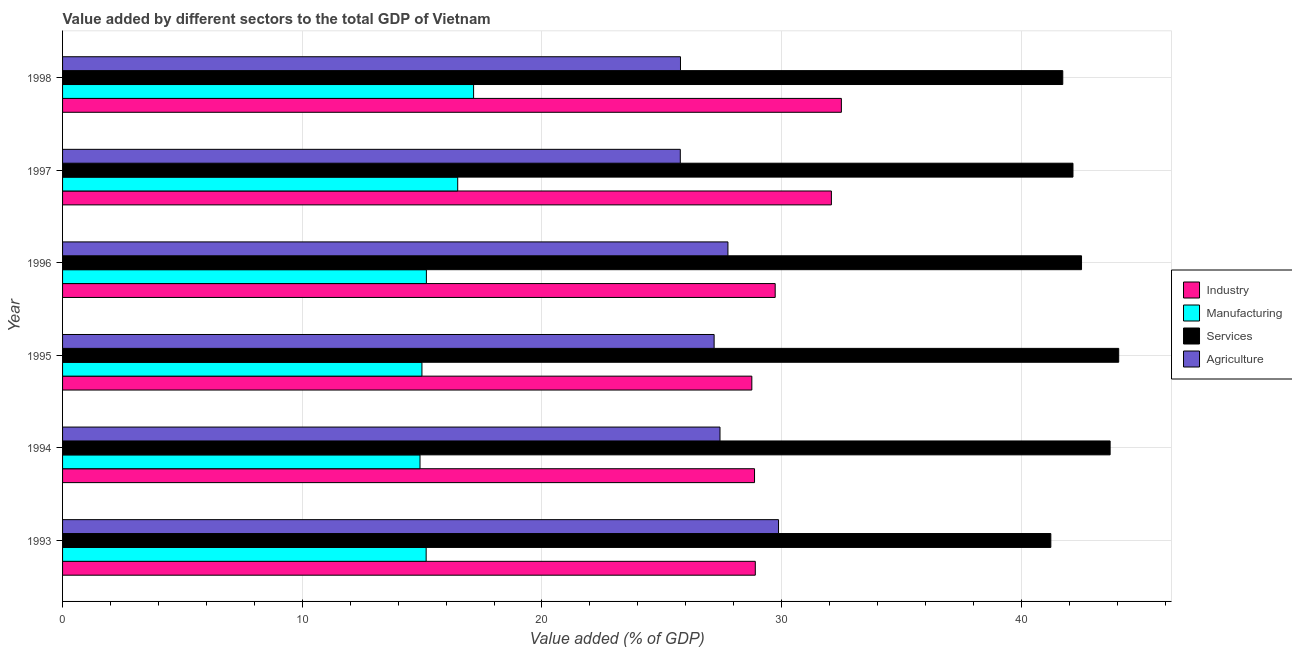How many groups of bars are there?
Ensure brevity in your answer.  6. Are the number of bars per tick equal to the number of legend labels?
Your answer should be compact. Yes. Are the number of bars on each tick of the Y-axis equal?
Provide a short and direct response. Yes. What is the value added by services sector in 1996?
Ensure brevity in your answer.  42.51. Across all years, what is the maximum value added by industrial sector?
Your answer should be very brief. 32.49. Across all years, what is the minimum value added by manufacturing sector?
Your answer should be very brief. 14.91. In which year was the value added by manufacturing sector maximum?
Make the answer very short. 1998. What is the total value added by industrial sector in the graph?
Make the answer very short. 180.82. What is the difference between the value added by agricultural sector in 1996 and that in 1997?
Offer a very short reply. 1.99. What is the difference between the value added by services sector in 1997 and the value added by industrial sector in 1993?
Provide a short and direct response. 13.25. What is the average value added by manufacturing sector per year?
Your answer should be very brief. 15.65. In the year 1998, what is the difference between the value added by manufacturing sector and value added by industrial sector?
Your answer should be compact. -15.34. What is the ratio of the value added by agricultural sector in 1994 to that in 1998?
Keep it short and to the point. 1.06. Is the difference between the value added by manufacturing sector in 1995 and 1998 greater than the difference between the value added by agricultural sector in 1995 and 1998?
Your answer should be very brief. No. What is the difference between the highest and the second highest value added by agricultural sector?
Provide a short and direct response. 2.11. Is the sum of the value added by services sector in 1993 and 1995 greater than the maximum value added by agricultural sector across all years?
Ensure brevity in your answer.  Yes. What does the 2nd bar from the top in 1997 represents?
Your response must be concise. Services. What does the 4th bar from the bottom in 1993 represents?
Give a very brief answer. Agriculture. How many bars are there?
Offer a very short reply. 24. Are the values on the major ticks of X-axis written in scientific E-notation?
Provide a succinct answer. No. How many legend labels are there?
Offer a very short reply. 4. What is the title of the graph?
Keep it short and to the point. Value added by different sectors to the total GDP of Vietnam. Does "Social Assistance" appear as one of the legend labels in the graph?
Make the answer very short. No. What is the label or title of the X-axis?
Ensure brevity in your answer.  Value added (% of GDP). What is the label or title of the Y-axis?
Ensure brevity in your answer.  Year. What is the Value added (% of GDP) in Industry in 1993?
Offer a very short reply. 28.9. What is the Value added (% of GDP) of Manufacturing in 1993?
Your answer should be compact. 15.17. What is the Value added (% of GDP) of Services in 1993?
Provide a succinct answer. 41.23. What is the Value added (% of GDP) in Agriculture in 1993?
Give a very brief answer. 29.87. What is the Value added (% of GDP) in Industry in 1994?
Provide a short and direct response. 28.87. What is the Value added (% of GDP) in Manufacturing in 1994?
Your response must be concise. 14.91. What is the Value added (% of GDP) in Services in 1994?
Give a very brief answer. 43.7. What is the Value added (% of GDP) in Agriculture in 1994?
Offer a very short reply. 27.43. What is the Value added (% of GDP) of Industry in 1995?
Your response must be concise. 28.76. What is the Value added (% of GDP) of Manufacturing in 1995?
Your answer should be compact. 14.99. What is the Value added (% of GDP) in Services in 1995?
Offer a terse response. 44.06. What is the Value added (% of GDP) of Agriculture in 1995?
Make the answer very short. 27.18. What is the Value added (% of GDP) of Industry in 1996?
Offer a very short reply. 29.73. What is the Value added (% of GDP) of Manufacturing in 1996?
Offer a very short reply. 15.18. What is the Value added (% of GDP) of Services in 1996?
Your response must be concise. 42.51. What is the Value added (% of GDP) of Agriculture in 1996?
Keep it short and to the point. 27.76. What is the Value added (% of GDP) of Industry in 1997?
Your answer should be compact. 32.07. What is the Value added (% of GDP) of Manufacturing in 1997?
Your response must be concise. 16.48. What is the Value added (% of GDP) of Services in 1997?
Give a very brief answer. 42.15. What is the Value added (% of GDP) of Agriculture in 1997?
Your answer should be compact. 25.77. What is the Value added (% of GDP) of Industry in 1998?
Provide a succinct answer. 32.49. What is the Value added (% of GDP) of Manufacturing in 1998?
Give a very brief answer. 17.15. What is the Value added (% of GDP) in Services in 1998?
Your answer should be compact. 41.73. What is the Value added (% of GDP) of Agriculture in 1998?
Your answer should be compact. 25.78. Across all years, what is the maximum Value added (% of GDP) in Industry?
Offer a terse response. 32.49. Across all years, what is the maximum Value added (% of GDP) in Manufacturing?
Your answer should be compact. 17.15. Across all years, what is the maximum Value added (% of GDP) of Services?
Provide a short and direct response. 44.06. Across all years, what is the maximum Value added (% of GDP) of Agriculture?
Offer a very short reply. 29.87. Across all years, what is the minimum Value added (% of GDP) in Industry?
Provide a short and direct response. 28.76. Across all years, what is the minimum Value added (% of GDP) of Manufacturing?
Offer a very short reply. 14.91. Across all years, what is the minimum Value added (% of GDP) of Services?
Keep it short and to the point. 41.23. Across all years, what is the minimum Value added (% of GDP) of Agriculture?
Provide a succinct answer. 25.77. What is the total Value added (% of GDP) of Industry in the graph?
Provide a short and direct response. 180.82. What is the total Value added (% of GDP) of Manufacturing in the graph?
Keep it short and to the point. 93.89. What is the total Value added (% of GDP) in Services in the graph?
Offer a very short reply. 255.39. What is the total Value added (% of GDP) in Agriculture in the graph?
Your response must be concise. 163.79. What is the difference between the Value added (% of GDP) in Industry in 1993 and that in 1994?
Offer a very short reply. 0.03. What is the difference between the Value added (% of GDP) in Manufacturing in 1993 and that in 1994?
Offer a very short reply. 0.26. What is the difference between the Value added (% of GDP) of Services in 1993 and that in 1994?
Your response must be concise. -2.47. What is the difference between the Value added (% of GDP) of Agriculture in 1993 and that in 1994?
Give a very brief answer. 2.44. What is the difference between the Value added (% of GDP) in Industry in 1993 and that in 1995?
Your answer should be compact. 0.14. What is the difference between the Value added (% of GDP) of Manufacturing in 1993 and that in 1995?
Ensure brevity in your answer.  0.18. What is the difference between the Value added (% of GDP) in Services in 1993 and that in 1995?
Offer a terse response. -2.83. What is the difference between the Value added (% of GDP) in Agriculture in 1993 and that in 1995?
Keep it short and to the point. 2.69. What is the difference between the Value added (% of GDP) in Industry in 1993 and that in 1996?
Provide a short and direct response. -0.83. What is the difference between the Value added (% of GDP) in Manufacturing in 1993 and that in 1996?
Offer a very short reply. -0.01. What is the difference between the Value added (% of GDP) in Services in 1993 and that in 1996?
Your response must be concise. -1.28. What is the difference between the Value added (% of GDP) in Agriculture in 1993 and that in 1996?
Give a very brief answer. 2.11. What is the difference between the Value added (% of GDP) of Industry in 1993 and that in 1997?
Give a very brief answer. -3.17. What is the difference between the Value added (% of GDP) of Manufacturing in 1993 and that in 1997?
Make the answer very short. -1.32. What is the difference between the Value added (% of GDP) of Services in 1993 and that in 1997?
Give a very brief answer. -0.92. What is the difference between the Value added (% of GDP) in Agriculture in 1993 and that in 1997?
Provide a succinct answer. 4.1. What is the difference between the Value added (% of GDP) of Industry in 1993 and that in 1998?
Provide a succinct answer. -3.59. What is the difference between the Value added (% of GDP) in Manufacturing in 1993 and that in 1998?
Offer a terse response. -1.98. What is the difference between the Value added (% of GDP) in Services in 1993 and that in 1998?
Give a very brief answer. -0.5. What is the difference between the Value added (% of GDP) of Agriculture in 1993 and that in 1998?
Keep it short and to the point. 4.09. What is the difference between the Value added (% of GDP) of Industry in 1994 and that in 1995?
Give a very brief answer. 0.11. What is the difference between the Value added (% of GDP) in Manufacturing in 1994 and that in 1995?
Your response must be concise. -0.08. What is the difference between the Value added (% of GDP) of Services in 1994 and that in 1995?
Your answer should be compact. -0.36. What is the difference between the Value added (% of GDP) of Agriculture in 1994 and that in 1995?
Your response must be concise. 0.25. What is the difference between the Value added (% of GDP) in Industry in 1994 and that in 1996?
Offer a very short reply. -0.86. What is the difference between the Value added (% of GDP) of Manufacturing in 1994 and that in 1996?
Offer a very short reply. -0.27. What is the difference between the Value added (% of GDP) in Services in 1994 and that in 1996?
Your response must be concise. 1.19. What is the difference between the Value added (% of GDP) of Agriculture in 1994 and that in 1996?
Keep it short and to the point. -0.33. What is the difference between the Value added (% of GDP) in Industry in 1994 and that in 1997?
Your answer should be compact. -3.21. What is the difference between the Value added (% of GDP) of Manufacturing in 1994 and that in 1997?
Offer a very short reply. -1.57. What is the difference between the Value added (% of GDP) in Services in 1994 and that in 1997?
Provide a short and direct response. 1.55. What is the difference between the Value added (% of GDP) in Agriculture in 1994 and that in 1997?
Offer a very short reply. 1.66. What is the difference between the Value added (% of GDP) of Industry in 1994 and that in 1998?
Ensure brevity in your answer.  -3.62. What is the difference between the Value added (% of GDP) in Manufacturing in 1994 and that in 1998?
Keep it short and to the point. -2.24. What is the difference between the Value added (% of GDP) in Services in 1994 and that in 1998?
Give a very brief answer. 1.98. What is the difference between the Value added (% of GDP) in Agriculture in 1994 and that in 1998?
Give a very brief answer. 1.65. What is the difference between the Value added (% of GDP) in Industry in 1995 and that in 1996?
Keep it short and to the point. -0.97. What is the difference between the Value added (% of GDP) of Manufacturing in 1995 and that in 1996?
Your answer should be compact. -0.19. What is the difference between the Value added (% of GDP) in Services in 1995 and that in 1996?
Your answer should be very brief. 1.55. What is the difference between the Value added (% of GDP) in Agriculture in 1995 and that in 1996?
Offer a very short reply. -0.58. What is the difference between the Value added (% of GDP) in Industry in 1995 and that in 1997?
Provide a short and direct response. -3.32. What is the difference between the Value added (% of GDP) of Manufacturing in 1995 and that in 1997?
Your answer should be compact. -1.49. What is the difference between the Value added (% of GDP) in Services in 1995 and that in 1997?
Provide a short and direct response. 1.91. What is the difference between the Value added (% of GDP) of Agriculture in 1995 and that in 1997?
Give a very brief answer. 1.41. What is the difference between the Value added (% of GDP) of Industry in 1995 and that in 1998?
Provide a succinct answer. -3.74. What is the difference between the Value added (% of GDP) in Manufacturing in 1995 and that in 1998?
Keep it short and to the point. -2.15. What is the difference between the Value added (% of GDP) of Services in 1995 and that in 1998?
Ensure brevity in your answer.  2.33. What is the difference between the Value added (% of GDP) of Agriculture in 1995 and that in 1998?
Ensure brevity in your answer.  1.4. What is the difference between the Value added (% of GDP) of Industry in 1996 and that in 1997?
Keep it short and to the point. -2.34. What is the difference between the Value added (% of GDP) of Manufacturing in 1996 and that in 1997?
Your response must be concise. -1.31. What is the difference between the Value added (% of GDP) in Services in 1996 and that in 1997?
Offer a very short reply. 0.36. What is the difference between the Value added (% of GDP) of Agriculture in 1996 and that in 1997?
Provide a succinct answer. 1.99. What is the difference between the Value added (% of GDP) in Industry in 1996 and that in 1998?
Your answer should be very brief. -2.76. What is the difference between the Value added (% of GDP) of Manufacturing in 1996 and that in 1998?
Offer a terse response. -1.97. What is the difference between the Value added (% of GDP) of Services in 1996 and that in 1998?
Provide a short and direct response. 0.78. What is the difference between the Value added (% of GDP) in Agriculture in 1996 and that in 1998?
Your answer should be very brief. 1.98. What is the difference between the Value added (% of GDP) of Industry in 1997 and that in 1998?
Offer a terse response. -0.42. What is the difference between the Value added (% of GDP) in Manufacturing in 1997 and that in 1998?
Make the answer very short. -0.66. What is the difference between the Value added (% of GDP) in Services in 1997 and that in 1998?
Your answer should be compact. 0.43. What is the difference between the Value added (% of GDP) of Agriculture in 1997 and that in 1998?
Your response must be concise. -0.01. What is the difference between the Value added (% of GDP) of Industry in 1993 and the Value added (% of GDP) of Manufacturing in 1994?
Keep it short and to the point. 13.99. What is the difference between the Value added (% of GDP) of Industry in 1993 and the Value added (% of GDP) of Services in 1994?
Ensure brevity in your answer.  -14.8. What is the difference between the Value added (% of GDP) of Industry in 1993 and the Value added (% of GDP) of Agriculture in 1994?
Give a very brief answer. 1.47. What is the difference between the Value added (% of GDP) of Manufacturing in 1993 and the Value added (% of GDP) of Services in 1994?
Your answer should be very brief. -28.54. What is the difference between the Value added (% of GDP) of Manufacturing in 1993 and the Value added (% of GDP) of Agriculture in 1994?
Keep it short and to the point. -12.26. What is the difference between the Value added (% of GDP) in Services in 1993 and the Value added (% of GDP) in Agriculture in 1994?
Offer a terse response. 13.8. What is the difference between the Value added (% of GDP) of Industry in 1993 and the Value added (% of GDP) of Manufacturing in 1995?
Give a very brief answer. 13.91. What is the difference between the Value added (% of GDP) of Industry in 1993 and the Value added (% of GDP) of Services in 1995?
Give a very brief answer. -15.16. What is the difference between the Value added (% of GDP) in Industry in 1993 and the Value added (% of GDP) in Agriculture in 1995?
Provide a short and direct response. 1.72. What is the difference between the Value added (% of GDP) in Manufacturing in 1993 and the Value added (% of GDP) in Services in 1995?
Offer a very short reply. -28.89. What is the difference between the Value added (% of GDP) of Manufacturing in 1993 and the Value added (% of GDP) of Agriculture in 1995?
Provide a short and direct response. -12.01. What is the difference between the Value added (% of GDP) in Services in 1993 and the Value added (% of GDP) in Agriculture in 1995?
Your response must be concise. 14.05. What is the difference between the Value added (% of GDP) of Industry in 1993 and the Value added (% of GDP) of Manufacturing in 1996?
Your answer should be very brief. 13.72. What is the difference between the Value added (% of GDP) of Industry in 1993 and the Value added (% of GDP) of Services in 1996?
Keep it short and to the point. -13.61. What is the difference between the Value added (% of GDP) in Industry in 1993 and the Value added (% of GDP) in Agriculture in 1996?
Provide a short and direct response. 1.14. What is the difference between the Value added (% of GDP) in Manufacturing in 1993 and the Value added (% of GDP) in Services in 1996?
Keep it short and to the point. -27.34. What is the difference between the Value added (% of GDP) of Manufacturing in 1993 and the Value added (% of GDP) of Agriculture in 1996?
Your answer should be very brief. -12.59. What is the difference between the Value added (% of GDP) in Services in 1993 and the Value added (% of GDP) in Agriculture in 1996?
Offer a very short reply. 13.47. What is the difference between the Value added (% of GDP) of Industry in 1993 and the Value added (% of GDP) of Manufacturing in 1997?
Offer a terse response. 12.42. What is the difference between the Value added (% of GDP) in Industry in 1993 and the Value added (% of GDP) in Services in 1997?
Your response must be concise. -13.25. What is the difference between the Value added (% of GDP) in Industry in 1993 and the Value added (% of GDP) in Agriculture in 1997?
Ensure brevity in your answer.  3.13. What is the difference between the Value added (% of GDP) of Manufacturing in 1993 and the Value added (% of GDP) of Services in 1997?
Your answer should be compact. -26.98. What is the difference between the Value added (% of GDP) in Manufacturing in 1993 and the Value added (% of GDP) in Agriculture in 1997?
Your answer should be very brief. -10.6. What is the difference between the Value added (% of GDP) of Services in 1993 and the Value added (% of GDP) of Agriculture in 1997?
Provide a short and direct response. 15.46. What is the difference between the Value added (% of GDP) in Industry in 1993 and the Value added (% of GDP) in Manufacturing in 1998?
Ensure brevity in your answer.  11.75. What is the difference between the Value added (% of GDP) in Industry in 1993 and the Value added (% of GDP) in Services in 1998?
Your answer should be compact. -12.83. What is the difference between the Value added (% of GDP) of Industry in 1993 and the Value added (% of GDP) of Agriculture in 1998?
Offer a terse response. 3.12. What is the difference between the Value added (% of GDP) in Manufacturing in 1993 and the Value added (% of GDP) in Services in 1998?
Keep it short and to the point. -26.56. What is the difference between the Value added (% of GDP) of Manufacturing in 1993 and the Value added (% of GDP) of Agriculture in 1998?
Make the answer very short. -10.61. What is the difference between the Value added (% of GDP) in Services in 1993 and the Value added (% of GDP) in Agriculture in 1998?
Your answer should be very brief. 15.45. What is the difference between the Value added (% of GDP) of Industry in 1994 and the Value added (% of GDP) of Manufacturing in 1995?
Offer a very short reply. 13.88. What is the difference between the Value added (% of GDP) in Industry in 1994 and the Value added (% of GDP) in Services in 1995?
Your answer should be very brief. -15.19. What is the difference between the Value added (% of GDP) in Industry in 1994 and the Value added (% of GDP) in Agriculture in 1995?
Your answer should be compact. 1.69. What is the difference between the Value added (% of GDP) in Manufacturing in 1994 and the Value added (% of GDP) in Services in 1995?
Keep it short and to the point. -29.15. What is the difference between the Value added (% of GDP) of Manufacturing in 1994 and the Value added (% of GDP) of Agriculture in 1995?
Provide a short and direct response. -12.27. What is the difference between the Value added (% of GDP) of Services in 1994 and the Value added (% of GDP) of Agriculture in 1995?
Your answer should be compact. 16.52. What is the difference between the Value added (% of GDP) in Industry in 1994 and the Value added (% of GDP) in Manufacturing in 1996?
Your answer should be compact. 13.69. What is the difference between the Value added (% of GDP) of Industry in 1994 and the Value added (% of GDP) of Services in 1996?
Your response must be concise. -13.64. What is the difference between the Value added (% of GDP) in Industry in 1994 and the Value added (% of GDP) in Agriculture in 1996?
Ensure brevity in your answer.  1.11. What is the difference between the Value added (% of GDP) of Manufacturing in 1994 and the Value added (% of GDP) of Services in 1996?
Ensure brevity in your answer.  -27.6. What is the difference between the Value added (% of GDP) in Manufacturing in 1994 and the Value added (% of GDP) in Agriculture in 1996?
Ensure brevity in your answer.  -12.85. What is the difference between the Value added (% of GDP) in Services in 1994 and the Value added (% of GDP) in Agriculture in 1996?
Your response must be concise. 15.94. What is the difference between the Value added (% of GDP) of Industry in 1994 and the Value added (% of GDP) of Manufacturing in 1997?
Ensure brevity in your answer.  12.38. What is the difference between the Value added (% of GDP) in Industry in 1994 and the Value added (% of GDP) in Services in 1997?
Offer a terse response. -13.29. What is the difference between the Value added (% of GDP) of Industry in 1994 and the Value added (% of GDP) of Agriculture in 1997?
Make the answer very short. 3.1. What is the difference between the Value added (% of GDP) in Manufacturing in 1994 and the Value added (% of GDP) in Services in 1997?
Offer a terse response. -27.24. What is the difference between the Value added (% of GDP) in Manufacturing in 1994 and the Value added (% of GDP) in Agriculture in 1997?
Provide a succinct answer. -10.86. What is the difference between the Value added (% of GDP) of Services in 1994 and the Value added (% of GDP) of Agriculture in 1997?
Your response must be concise. 17.93. What is the difference between the Value added (% of GDP) in Industry in 1994 and the Value added (% of GDP) in Manufacturing in 1998?
Your answer should be very brief. 11.72. What is the difference between the Value added (% of GDP) in Industry in 1994 and the Value added (% of GDP) in Services in 1998?
Offer a very short reply. -12.86. What is the difference between the Value added (% of GDP) of Industry in 1994 and the Value added (% of GDP) of Agriculture in 1998?
Keep it short and to the point. 3.09. What is the difference between the Value added (% of GDP) in Manufacturing in 1994 and the Value added (% of GDP) in Services in 1998?
Your response must be concise. -26.82. What is the difference between the Value added (% of GDP) in Manufacturing in 1994 and the Value added (% of GDP) in Agriculture in 1998?
Your answer should be very brief. -10.87. What is the difference between the Value added (% of GDP) of Services in 1994 and the Value added (% of GDP) of Agriculture in 1998?
Make the answer very short. 17.92. What is the difference between the Value added (% of GDP) of Industry in 1995 and the Value added (% of GDP) of Manufacturing in 1996?
Provide a short and direct response. 13.58. What is the difference between the Value added (% of GDP) in Industry in 1995 and the Value added (% of GDP) in Services in 1996?
Make the answer very short. -13.76. What is the difference between the Value added (% of GDP) in Industry in 1995 and the Value added (% of GDP) in Agriculture in 1996?
Make the answer very short. 1. What is the difference between the Value added (% of GDP) of Manufacturing in 1995 and the Value added (% of GDP) of Services in 1996?
Your response must be concise. -27.52. What is the difference between the Value added (% of GDP) of Manufacturing in 1995 and the Value added (% of GDP) of Agriculture in 1996?
Your response must be concise. -12.77. What is the difference between the Value added (% of GDP) of Services in 1995 and the Value added (% of GDP) of Agriculture in 1996?
Your response must be concise. 16.3. What is the difference between the Value added (% of GDP) in Industry in 1995 and the Value added (% of GDP) in Manufacturing in 1997?
Your answer should be compact. 12.27. What is the difference between the Value added (% of GDP) of Industry in 1995 and the Value added (% of GDP) of Services in 1997?
Provide a short and direct response. -13.4. What is the difference between the Value added (% of GDP) of Industry in 1995 and the Value added (% of GDP) of Agriculture in 1997?
Ensure brevity in your answer.  2.98. What is the difference between the Value added (% of GDP) of Manufacturing in 1995 and the Value added (% of GDP) of Services in 1997?
Offer a terse response. -27.16. What is the difference between the Value added (% of GDP) in Manufacturing in 1995 and the Value added (% of GDP) in Agriculture in 1997?
Provide a succinct answer. -10.78. What is the difference between the Value added (% of GDP) in Services in 1995 and the Value added (% of GDP) in Agriculture in 1997?
Ensure brevity in your answer.  18.29. What is the difference between the Value added (% of GDP) of Industry in 1995 and the Value added (% of GDP) of Manufacturing in 1998?
Provide a short and direct response. 11.61. What is the difference between the Value added (% of GDP) in Industry in 1995 and the Value added (% of GDP) in Services in 1998?
Offer a terse response. -12.97. What is the difference between the Value added (% of GDP) of Industry in 1995 and the Value added (% of GDP) of Agriculture in 1998?
Offer a terse response. 2.98. What is the difference between the Value added (% of GDP) in Manufacturing in 1995 and the Value added (% of GDP) in Services in 1998?
Ensure brevity in your answer.  -26.73. What is the difference between the Value added (% of GDP) of Manufacturing in 1995 and the Value added (% of GDP) of Agriculture in 1998?
Ensure brevity in your answer.  -10.79. What is the difference between the Value added (% of GDP) in Services in 1995 and the Value added (% of GDP) in Agriculture in 1998?
Your answer should be compact. 18.28. What is the difference between the Value added (% of GDP) in Industry in 1996 and the Value added (% of GDP) in Manufacturing in 1997?
Make the answer very short. 13.25. What is the difference between the Value added (% of GDP) in Industry in 1996 and the Value added (% of GDP) in Services in 1997?
Keep it short and to the point. -12.42. What is the difference between the Value added (% of GDP) in Industry in 1996 and the Value added (% of GDP) in Agriculture in 1997?
Keep it short and to the point. 3.96. What is the difference between the Value added (% of GDP) of Manufacturing in 1996 and the Value added (% of GDP) of Services in 1997?
Your answer should be very brief. -26.98. What is the difference between the Value added (% of GDP) of Manufacturing in 1996 and the Value added (% of GDP) of Agriculture in 1997?
Ensure brevity in your answer.  -10.59. What is the difference between the Value added (% of GDP) of Services in 1996 and the Value added (% of GDP) of Agriculture in 1997?
Provide a succinct answer. 16.74. What is the difference between the Value added (% of GDP) of Industry in 1996 and the Value added (% of GDP) of Manufacturing in 1998?
Offer a very short reply. 12.58. What is the difference between the Value added (% of GDP) in Industry in 1996 and the Value added (% of GDP) in Services in 1998?
Provide a short and direct response. -12. What is the difference between the Value added (% of GDP) in Industry in 1996 and the Value added (% of GDP) in Agriculture in 1998?
Give a very brief answer. 3.95. What is the difference between the Value added (% of GDP) in Manufacturing in 1996 and the Value added (% of GDP) in Services in 1998?
Ensure brevity in your answer.  -26.55. What is the difference between the Value added (% of GDP) of Manufacturing in 1996 and the Value added (% of GDP) of Agriculture in 1998?
Give a very brief answer. -10.6. What is the difference between the Value added (% of GDP) of Services in 1996 and the Value added (% of GDP) of Agriculture in 1998?
Provide a short and direct response. 16.73. What is the difference between the Value added (% of GDP) in Industry in 1997 and the Value added (% of GDP) in Manufacturing in 1998?
Your answer should be very brief. 14.93. What is the difference between the Value added (% of GDP) in Industry in 1997 and the Value added (% of GDP) in Services in 1998?
Provide a short and direct response. -9.65. What is the difference between the Value added (% of GDP) of Industry in 1997 and the Value added (% of GDP) of Agriculture in 1998?
Offer a terse response. 6.3. What is the difference between the Value added (% of GDP) of Manufacturing in 1997 and the Value added (% of GDP) of Services in 1998?
Provide a succinct answer. -25.24. What is the difference between the Value added (% of GDP) of Manufacturing in 1997 and the Value added (% of GDP) of Agriculture in 1998?
Your answer should be compact. -9.29. What is the difference between the Value added (% of GDP) of Services in 1997 and the Value added (% of GDP) of Agriculture in 1998?
Offer a terse response. 16.37. What is the average Value added (% of GDP) of Industry per year?
Your answer should be very brief. 30.14. What is the average Value added (% of GDP) of Manufacturing per year?
Your answer should be compact. 15.65. What is the average Value added (% of GDP) in Services per year?
Provide a short and direct response. 42.56. What is the average Value added (% of GDP) of Agriculture per year?
Give a very brief answer. 27.3. In the year 1993, what is the difference between the Value added (% of GDP) in Industry and Value added (% of GDP) in Manufacturing?
Your answer should be compact. 13.73. In the year 1993, what is the difference between the Value added (% of GDP) of Industry and Value added (% of GDP) of Services?
Make the answer very short. -12.33. In the year 1993, what is the difference between the Value added (% of GDP) in Industry and Value added (% of GDP) in Agriculture?
Your response must be concise. -0.97. In the year 1993, what is the difference between the Value added (% of GDP) of Manufacturing and Value added (% of GDP) of Services?
Make the answer very short. -26.06. In the year 1993, what is the difference between the Value added (% of GDP) in Manufacturing and Value added (% of GDP) in Agriculture?
Provide a succinct answer. -14.7. In the year 1993, what is the difference between the Value added (% of GDP) in Services and Value added (% of GDP) in Agriculture?
Provide a short and direct response. 11.36. In the year 1994, what is the difference between the Value added (% of GDP) in Industry and Value added (% of GDP) in Manufacturing?
Offer a very short reply. 13.96. In the year 1994, what is the difference between the Value added (% of GDP) in Industry and Value added (% of GDP) in Services?
Keep it short and to the point. -14.84. In the year 1994, what is the difference between the Value added (% of GDP) of Industry and Value added (% of GDP) of Agriculture?
Your answer should be very brief. 1.44. In the year 1994, what is the difference between the Value added (% of GDP) of Manufacturing and Value added (% of GDP) of Services?
Provide a short and direct response. -28.79. In the year 1994, what is the difference between the Value added (% of GDP) of Manufacturing and Value added (% of GDP) of Agriculture?
Give a very brief answer. -12.52. In the year 1994, what is the difference between the Value added (% of GDP) of Services and Value added (% of GDP) of Agriculture?
Provide a short and direct response. 16.28. In the year 1995, what is the difference between the Value added (% of GDP) in Industry and Value added (% of GDP) in Manufacturing?
Keep it short and to the point. 13.76. In the year 1995, what is the difference between the Value added (% of GDP) of Industry and Value added (% of GDP) of Services?
Provide a succinct answer. -15.31. In the year 1995, what is the difference between the Value added (% of GDP) in Industry and Value added (% of GDP) in Agriculture?
Keep it short and to the point. 1.57. In the year 1995, what is the difference between the Value added (% of GDP) in Manufacturing and Value added (% of GDP) in Services?
Your answer should be compact. -29.07. In the year 1995, what is the difference between the Value added (% of GDP) in Manufacturing and Value added (% of GDP) in Agriculture?
Provide a succinct answer. -12.19. In the year 1995, what is the difference between the Value added (% of GDP) in Services and Value added (% of GDP) in Agriculture?
Offer a terse response. 16.88. In the year 1996, what is the difference between the Value added (% of GDP) of Industry and Value added (% of GDP) of Manufacturing?
Provide a short and direct response. 14.55. In the year 1996, what is the difference between the Value added (% of GDP) in Industry and Value added (% of GDP) in Services?
Offer a terse response. -12.78. In the year 1996, what is the difference between the Value added (% of GDP) in Industry and Value added (% of GDP) in Agriculture?
Offer a terse response. 1.97. In the year 1996, what is the difference between the Value added (% of GDP) of Manufacturing and Value added (% of GDP) of Services?
Offer a terse response. -27.33. In the year 1996, what is the difference between the Value added (% of GDP) in Manufacturing and Value added (% of GDP) in Agriculture?
Ensure brevity in your answer.  -12.58. In the year 1996, what is the difference between the Value added (% of GDP) of Services and Value added (% of GDP) of Agriculture?
Keep it short and to the point. 14.75. In the year 1997, what is the difference between the Value added (% of GDP) in Industry and Value added (% of GDP) in Manufacturing?
Your answer should be compact. 15.59. In the year 1997, what is the difference between the Value added (% of GDP) in Industry and Value added (% of GDP) in Services?
Your answer should be very brief. -10.08. In the year 1997, what is the difference between the Value added (% of GDP) in Industry and Value added (% of GDP) in Agriculture?
Offer a terse response. 6.3. In the year 1997, what is the difference between the Value added (% of GDP) in Manufacturing and Value added (% of GDP) in Services?
Keep it short and to the point. -25.67. In the year 1997, what is the difference between the Value added (% of GDP) in Manufacturing and Value added (% of GDP) in Agriculture?
Offer a very short reply. -9.29. In the year 1997, what is the difference between the Value added (% of GDP) of Services and Value added (% of GDP) of Agriculture?
Make the answer very short. 16.38. In the year 1998, what is the difference between the Value added (% of GDP) of Industry and Value added (% of GDP) of Manufacturing?
Keep it short and to the point. 15.34. In the year 1998, what is the difference between the Value added (% of GDP) in Industry and Value added (% of GDP) in Services?
Keep it short and to the point. -9.24. In the year 1998, what is the difference between the Value added (% of GDP) in Industry and Value added (% of GDP) in Agriculture?
Make the answer very short. 6.71. In the year 1998, what is the difference between the Value added (% of GDP) of Manufacturing and Value added (% of GDP) of Services?
Give a very brief answer. -24.58. In the year 1998, what is the difference between the Value added (% of GDP) of Manufacturing and Value added (% of GDP) of Agriculture?
Your answer should be compact. -8.63. In the year 1998, what is the difference between the Value added (% of GDP) in Services and Value added (% of GDP) in Agriculture?
Make the answer very short. 15.95. What is the ratio of the Value added (% of GDP) in Industry in 1993 to that in 1994?
Give a very brief answer. 1. What is the ratio of the Value added (% of GDP) of Manufacturing in 1993 to that in 1994?
Ensure brevity in your answer.  1.02. What is the ratio of the Value added (% of GDP) of Services in 1993 to that in 1994?
Provide a succinct answer. 0.94. What is the ratio of the Value added (% of GDP) of Agriculture in 1993 to that in 1994?
Provide a succinct answer. 1.09. What is the ratio of the Value added (% of GDP) of Industry in 1993 to that in 1995?
Your answer should be compact. 1. What is the ratio of the Value added (% of GDP) of Manufacturing in 1993 to that in 1995?
Offer a very short reply. 1.01. What is the ratio of the Value added (% of GDP) of Services in 1993 to that in 1995?
Your answer should be very brief. 0.94. What is the ratio of the Value added (% of GDP) in Agriculture in 1993 to that in 1995?
Ensure brevity in your answer.  1.1. What is the ratio of the Value added (% of GDP) of Industry in 1993 to that in 1996?
Provide a short and direct response. 0.97. What is the ratio of the Value added (% of GDP) of Services in 1993 to that in 1996?
Keep it short and to the point. 0.97. What is the ratio of the Value added (% of GDP) in Agriculture in 1993 to that in 1996?
Ensure brevity in your answer.  1.08. What is the ratio of the Value added (% of GDP) in Industry in 1993 to that in 1997?
Offer a very short reply. 0.9. What is the ratio of the Value added (% of GDP) of Manufacturing in 1993 to that in 1997?
Keep it short and to the point. 0.92. What is the ratio of the Value added (% of GDP) of Services in 1993 to that in 1997?
Offer a terse response. 0.98. What is the ratio of the Value added (% of GDP) of Agriculture in 1993 to that in 1997?
Offer a terse response. 1.16. What is the ratio of the Value added (% of GDP) in Industry in 1993 to that in 1998?
Offer a terse response. 0.89. What is the ratio of the Value added (% of GDP) of Manufacturing in 1993 to that in 1998?
Make the answer very short. 0.88. What is the ratio of the Value added (% of GDP) in Services in 1993 to that in 1998?
Give a very brief answer. 0.99. What is the ratio of the Value added (% of GDP) in Agriculture in 1993 to that in 1998?
Your response must be concise. 1.16. What is the ratio of the Value added (% of GDP) in Manufacturing in 1994 to that in 1995?
Provide a succinct answer. 0.99. What is the ratio of the Value added (% of GDP) in Services in 1994 to that in 1995?
Your response must be concise. 0.99. What is the ratio of the Value added (% of GDP) of Manufacturing in 1994 to that in 1996?
Offer a very short reply. 0.98. What is the ratio of the Value added (% of GDP) of Services in 1994 to that in 1996?
Your response must be concise. 1.03. What is the ratio of the Value added (% of GDP) in Agriculture in 1994 to that in 1996?
Your answer should be very brief. 0.99. What is the ratio of the Value added (% of GDP) of Manufacturing in 1994 to that in 1997?
Your answer should be compact. 0.9. What is the ratio of the Value added (% of GDP) of Services in 1994 to that in 1997?
Offer a very short reply. 1.04. What is the ratio of the Value added (% of GDP) in Agriculture in 1994 to that in 1997?
Your answer should be compact. 1.06. What is the ratio of the Value added (% of GDP) of Industry in 1994 to that in 1998?
Keep it short and to the point. 0.89. What is the ratio of the Value added (% of GDP) in Manufacturing in 1994 to that in 1998?
Ensure brevity in your answer.  0.87. What is the ratio of the Value added (% of GDP) of Services in 1994 to that in 1998?
Your response must be concise. 1.05. What is the ratio of the Value added (% of GDP) in Agriculture in 1994 to that in 1998?
Offer a terse response. 1.06. What is the ratio of the Value added (% of GDP) in Industry in 1995 to that in 1996?
Provide a short and direct response. 0.97. What is the ratio of the Value added (% of GDP) of Manufacturing in 1995 to that in 1996?
Ensure brevity in your answer.  0.99. What is the ratio of the Value added (% of GDP) of Services in 1995 to that in 1996?
Make the answer very short. 1.04. What is the ratio of the Value added (% of GDP) in Agriculture in 1995 to that in 1996?
Ensure brevity in your answer.  0.98. What is the ratio of the Value added (% of GDP) in Industry in 1995 to that in 1997?
Provide a succinct answer. 0.9. What is the ratio of the Value added (% of GDP) of Manufacturing in 1995 to that in 1997?
Your answer should be compact. 0.91. What is the ratio of the Value added (% of GDP) of Services in 1995 to that in 1997?
Make the answer very short. 1.05. What is the ratio of the Value added (% of GDP) of Agriculture in 1995 to that in 1997?
Offer a terse response. 1.05. What is the ratio of the Value added (% of GDP) of Industry in 1995 to that in 1998?
Your answer should be compact. 0.89. What is the ratio of the Value added (% of GDP) in Manufacturing in 1995 to that in 1998?
Provide a succinct answer. 0.87. What is the ratio of the Value added (% of GDP) in Services in 1995 to that in 1998?
Give a very brief answer. 1.06. What is the ratio of the Value added (% of GDP) in Agriculture in 1995 to that in 1998?
Keep it short and to the point. 1.05. What is the ratio of the Value added (% of GDP) of Industry in 1996 to that in 1997?
Your answer should be very brief. 0.93. What is the ratio of the Value added (% of GDP) of Manufacturing in 1996 to that in 1997?
Your answer should be very brief. 0.92. What is the ratio of the Value added (% of GDP) of Services in 1996 to that in 1997?
Offer a terse response. 1.01. What is the ratio of the Value added (% of GDP) in Agriculture in 1996 to that in 1997?
Keep it short and to the point. 1.08. What is the ratio of the Value added (% of GDP) of Industry in 1996 to that in 1998?
Your answer should be very brief. 0.92. What is the ratio of the Value added (% of GDP) of Manufacturing in 1996 to that in 1998?
Make the answer very short. 0.89. What is the ratio of the Value added (% of GDP) in Services in 1996 to that in 1998?
Your answer should be compact. 1.02. What is the ratio of the Value added (% of GDP) of Agriculture in 1996 to that in 1998?
Give a very brief answer. 1.08. What is the ratio of the Value added (% of GDP) in Industry in 1997 to that in 1998?
Your response must be concise. 0.99. What is the ratio of the Value added (% of GDP) in Manufacturing in 1997 to that in 1998?
Your answer should be compact. 0.96. What is the ratio of the Value added (% of GDP) of Services in 1997 to that in 1998?
Provide a short and direct response. 1.01. What is the ratio of the Value added (% of GDP) in Agriculture in 1997 to that in 1998?
Your answer should be compact. 1. What is the difference between the highest and the second highest Value added (% of GDP) of Industry?
Keep it short and to the point. 0.42. What is the difference between the highest and the second highest Value added (% of GDP) in Manufacturing?
Ensure brevity in your answer.  0.66. What is the difference between the highest and the second highest Value added (% of GDP) of Services?
Keep it short and to the point. 0.36. What is the difference between the highest and the second highest Value added (% of GDP) in Agriculture?
Make the answer very short. 2.11. What is the difference between the highest and the lowest Value added (% of GDP) in Industry?
Offer a very short reply. 3.74. What is the difference between the highest and the lowest Value added (% of GDP) in Manufacturing?
Keep it short and to the point. 2.24. What is the difference between the highest and the lowest Value added (% of GDP) in Services?
Give a very brief answer. 2.83. What is the difference between the highest and the lowest Value added (% of GDP) of Agriculture?
Make the answer very short. 4.1. 